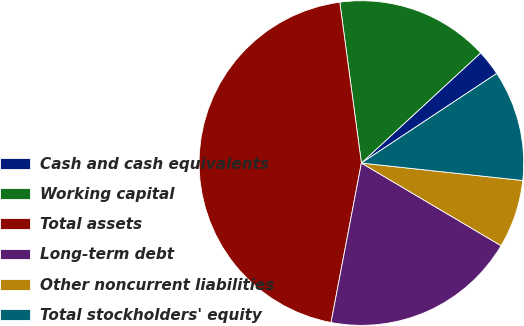<chart> <loc_0><loc_0><loc_500><loc_500><pie_chart><fcel>Cash and cash equivalents<fcel>Working capital<fcel>Total assets<fcel>Long-term debt<fcel>Other noncurrent liabilities<fcel>Total stockholders' equity<nl><fcel>2.56%<fcel>15.26%<fcel>44.88%<fcel>19.49%<fcel>6.79%<fcel>11.02%<nl></chart> 